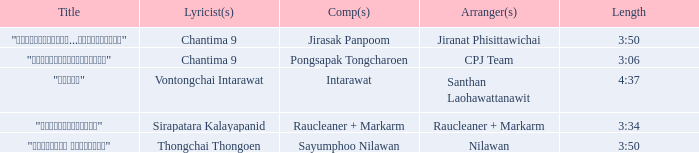Who was the composer of "ขอโทษ"? Intarawat. 